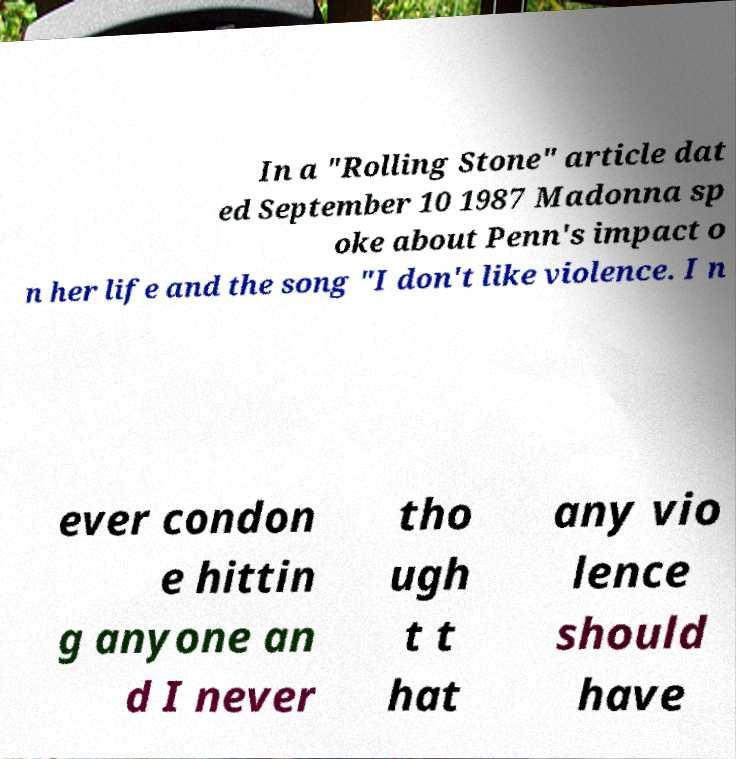Please read and relay the text visible in this image. What does it say? In a "Rolling Stone" article dat ed September 10 1987 Madonna sp oke about Penn's impact o n her life and the song "I don't like violence. I n ever condon e hittin g anyone an d I never tho ugh t t hat any vio lence should have 